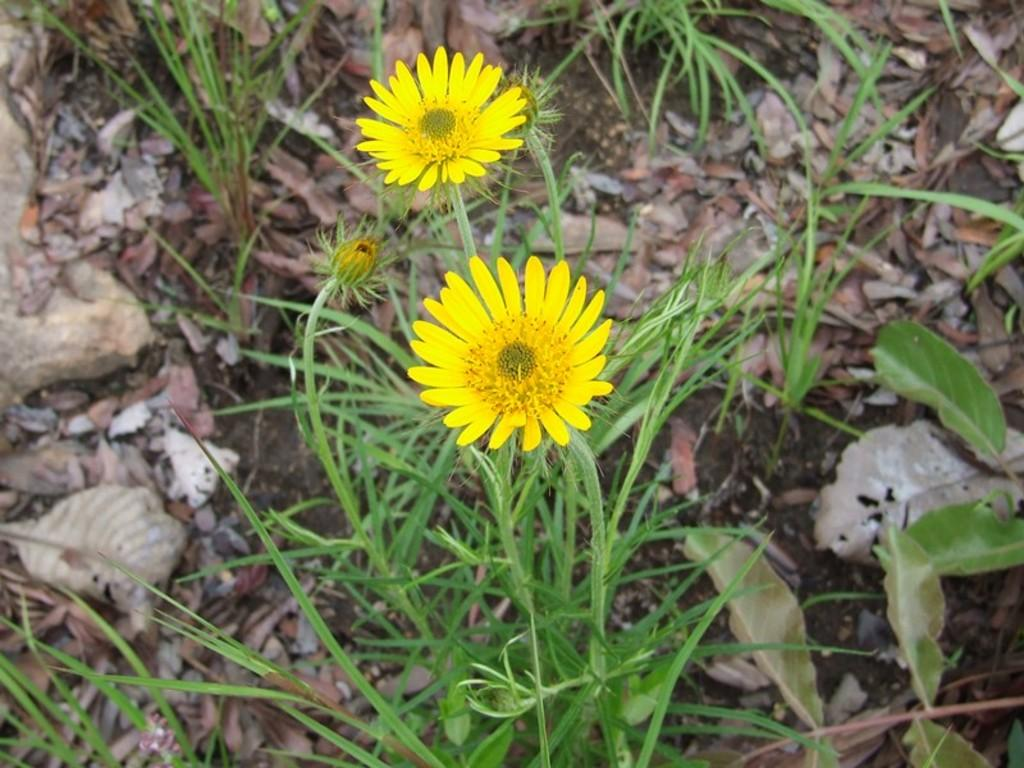How many flowers can be seen in the image? There are two flowers in the image. What other types of plant life are present in the image? There are plants in the image. What can be observed on the ground in the image? Dried leaves are present on the ground in the image. How many men are holding a wrench in the image? There are no men or wrenches present in the image; it features flowers and plants. What type of bird can be seen perched on the flowers in the image? There are no birds present in the image; it only features flowers, plants, and dried leaves on the ground. 